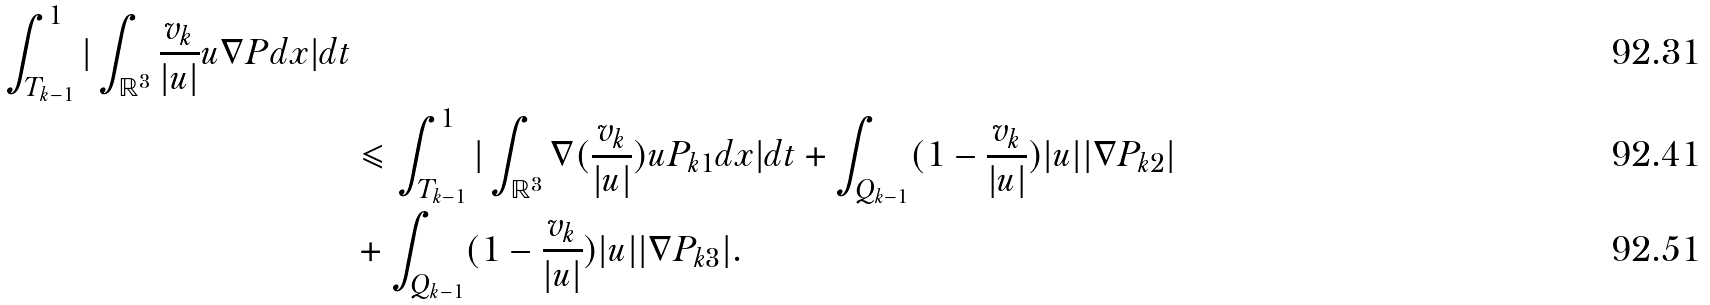Convert formula to latex. <formula><loc_0><loc_0><loc_500><loc_500>\int _ { T _ { k - 1 } } ^ { 1 } | \int _ { \mathbb { R } ^ { 3 } } \frac { v _ { k } } { | u | } u \nabla P d x | d t \\ & \leqslant \int _ { T _ { k - 1 } } ^ { 1 } | \int _ { \mathbb { R } ^ { 3 } } \nabla ( \frac { v _ { k } } { | u | } ) u P _ { k 1 } d x | d t + \int _ { Q _ { k - 1 } } ( 1 - \frac { v _ { k } } { | u | } ) | u | | \nabla P _ { k 2 } | \\ & + \int _ { Q _ { k - 1 } } ( 1 - \frac { v _ { k } } { | u | } ) | u | | \nabla P _ { k 3 } | .</formula> 